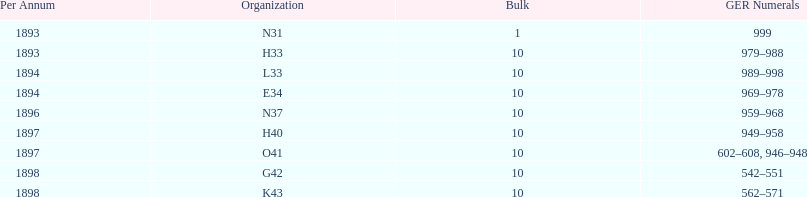What is the number of years with a quantity of 10? 5. 